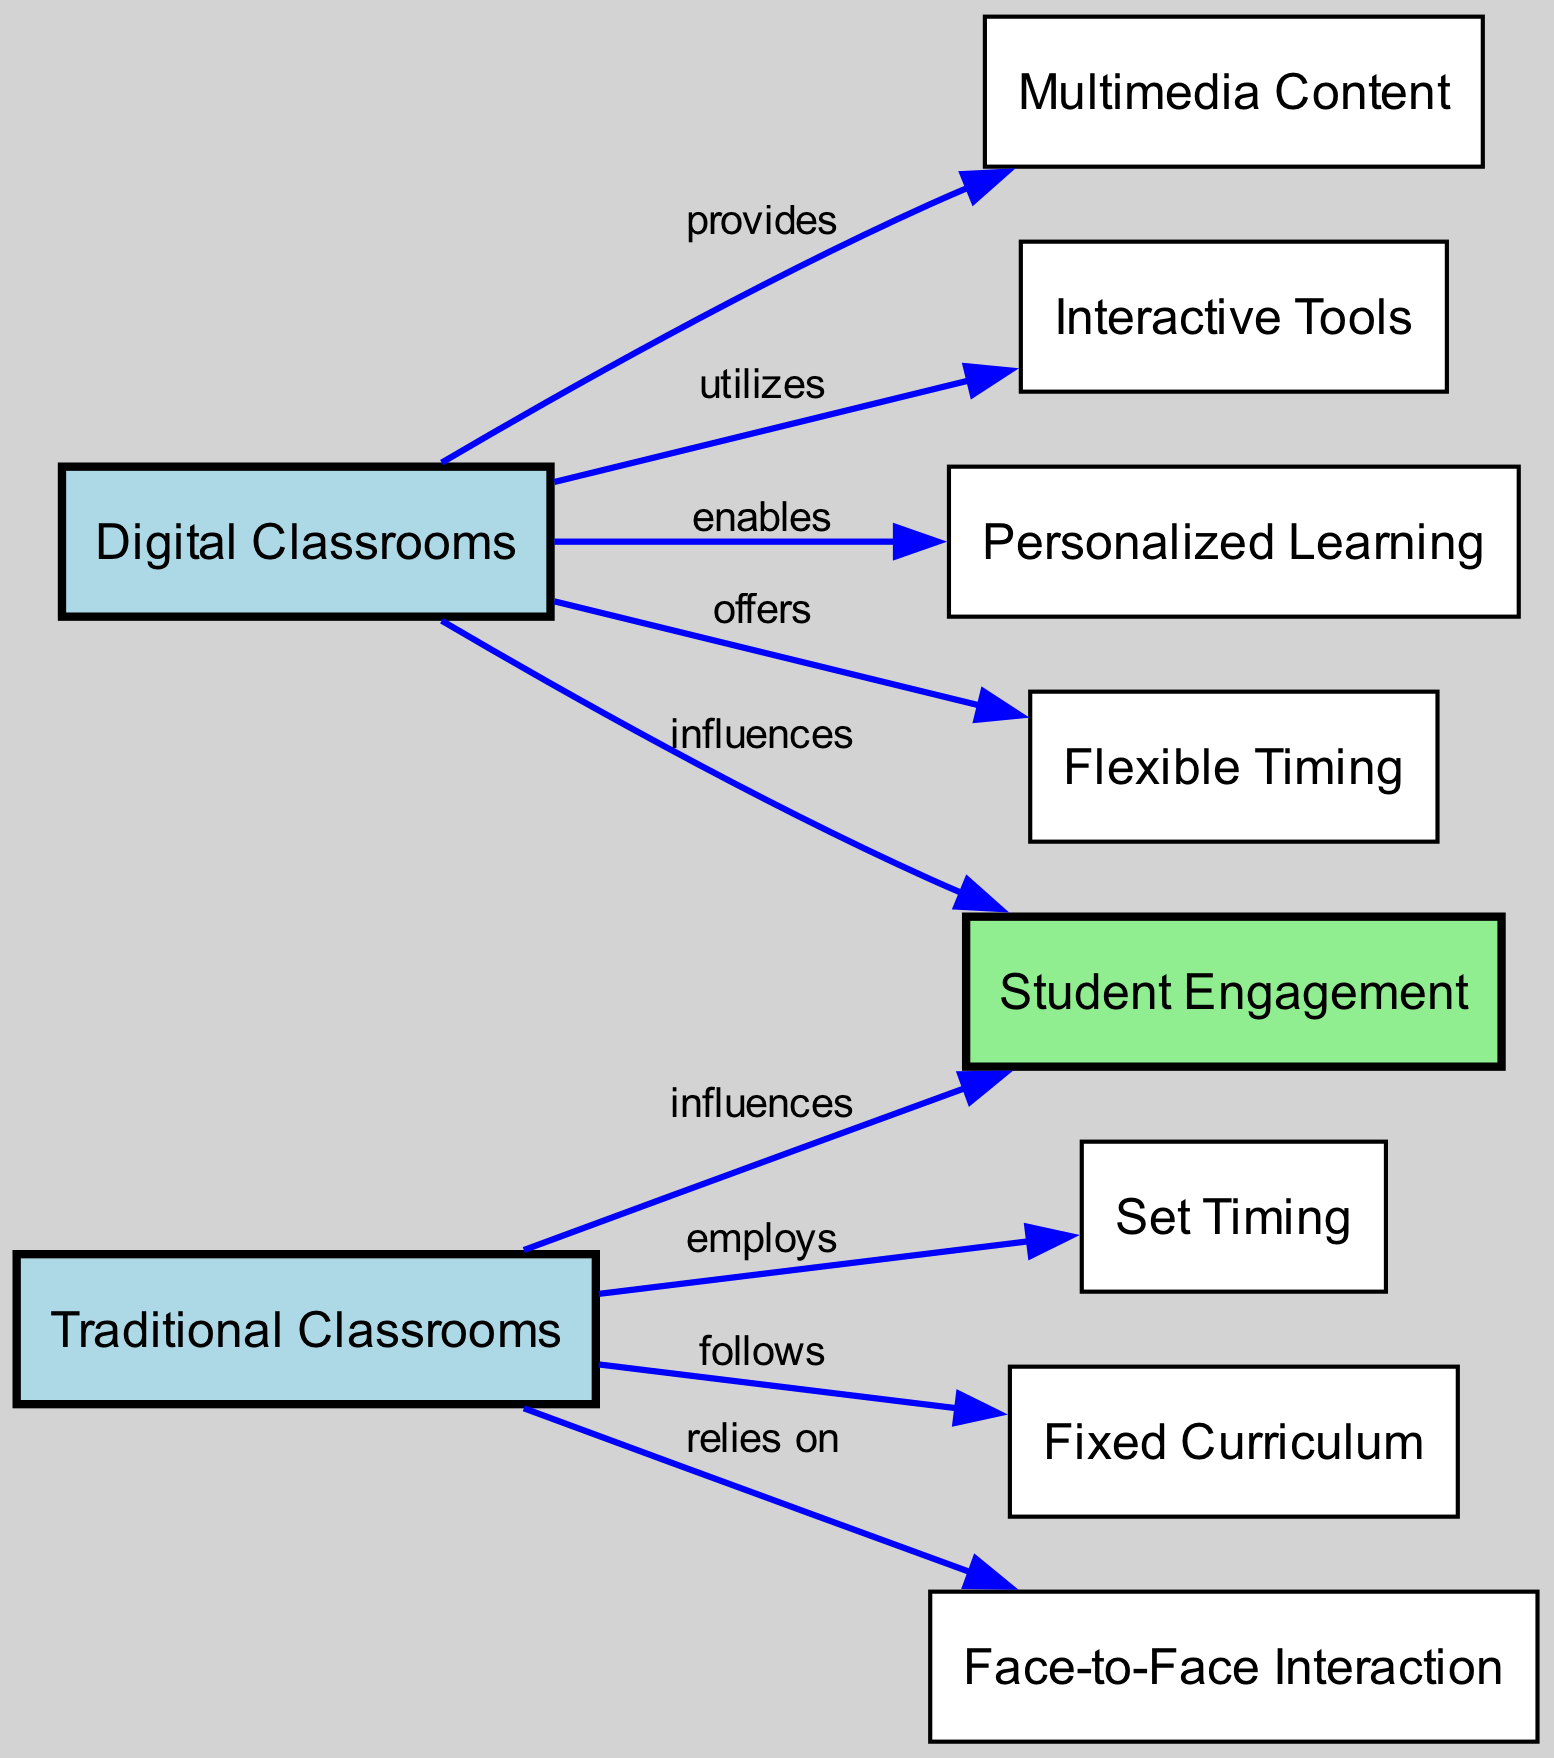What are the two types of classrooms in the diagram? The diagram includes two nodes representing different types of classrooms: "Digital Classrooms" and "Traditional Classrooms." These nodes provide a clear categorization of the educational settings being compared.
Answer: Digital Classrooms, Traditional Classrooms How many nodes are there in the diagram? The diagram consists of ten nodes, which include different elements related to both classroom types and their impact on student engagement. Counting each unique element listed in the data, we arrive at a total of ten nodes.
Answer: 10 Which type of classroom influences student engagement the most? Both "Digital Classrooms" and "Traditional Classrooms" are shown as having an influence on "Student Engagement." However, the specific degree of influence for each type is not explicitly stated in the diagram. Thus, it's unclear which one has a greater impact.
Answer: Both influence equally What does "Digital Classrooms" provide? According to the diagram, "Digital Classrooms" provides "Multimedia Content." This is indicated by a directed edge from "Digital Classrooms" to "Multimedia Content," signifying a direct contribution of resources.
Answer: Multimedia Content What kind of curriculum does "Traditional Classrooms" follow? The diagram indicates that "Traditional Classrooms" follows a "Fixed Curriculum." This relationship is shown by the edge connecting "Traditional Classrooms" to "Fixed Curriculum," pointing to a structured approach in this learning environment.
Answer: Fixed Curriculum Which elements are utilized by "Digital Classrooms"? The elements "Interactive Tools" and "Multimedia Content" are utilized by "Digital Classrooms." The connections emanating from "Digital Classrooms" to these two nodes confirm their role in enhancing the digital learning experience.
Answer: Interactive Tools, Multimedia Content How does "Digital Classrooms" enhance personalized learning? "Digital Classrooms" enables "Personalized Learning," illustrated by a direct edge between these two nodes. This connection implies that through the features of digital learning, tailored educational experiences can be offered to students.
Answer: Enables Personalized Learning What reliance does "Traditional Classrooms" have? "Traditional Classrooms" relies on "Face-to-Face Interaction." The diagram depicts a clear edge from "Traditional Classrooms" to "Face-to-Face Interaction," highlighting the importance of personal interaction in this model of education.
Answer: Face-to-Face Interaction What is the timing structure in "Traditional Classrooms"? The structure of timing in "Traditional Classrooms" is defined by "Set Timing." This relationship is established by the diagram's edge from "Traditional Classrooms" to "Set Timing," indicating a fixed schedule for lessons.
Answer: Set Timing In what way do "Digital Classrooms" offer flexibility? "Digital Classrooms" offers "Flexible Timing," as noted by the edge connecting "Digital Classrooms" to "Flexible Timing." This signifies that students can have more control over their learning schedule compared to traditional methods.
Answer: Flexible Timing 